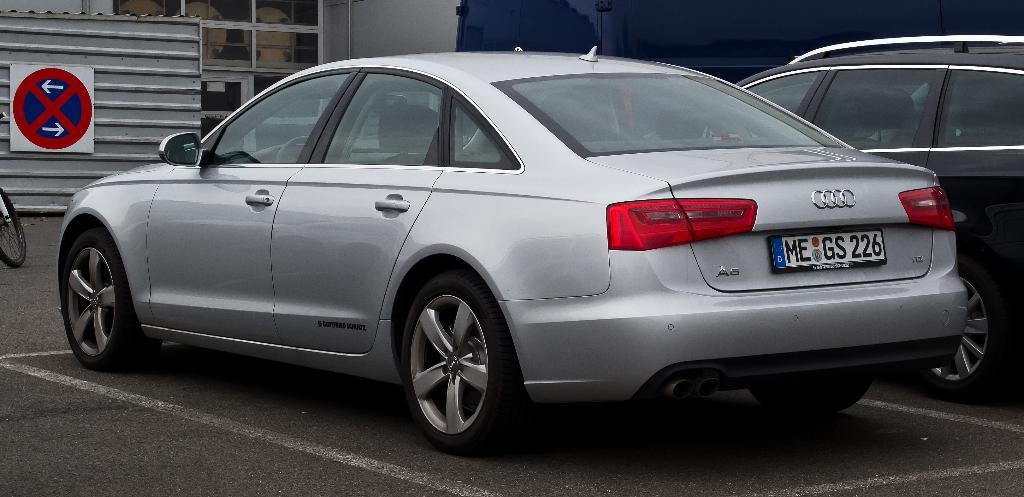<image>
Relay a brief, clear account of the picture shown. silver audi a6 with license plate me gs 226 parked in front of sign indicating no parking 